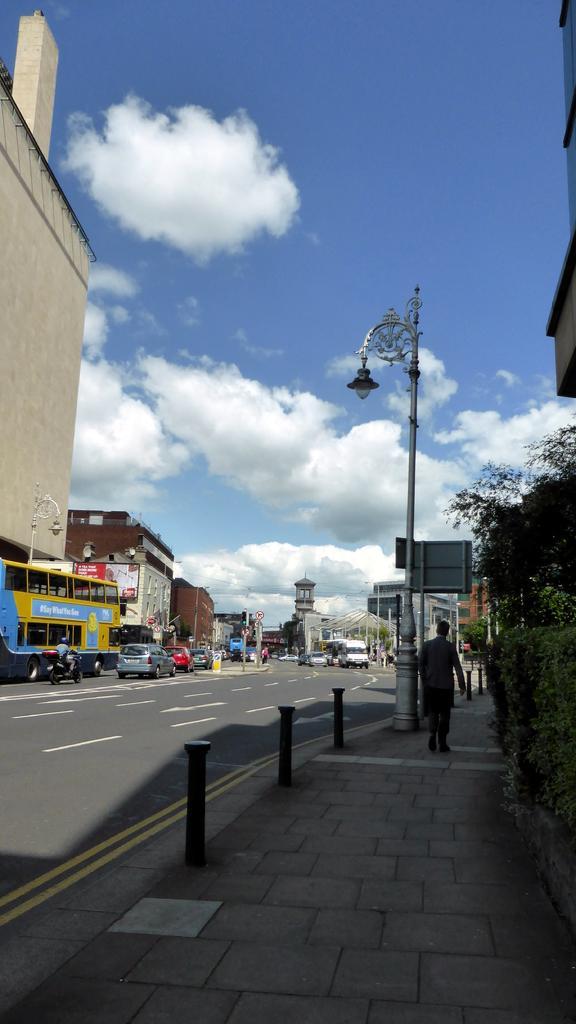Could you give a brief overview of what you see in this image? This picture shows few buildings and we see vehicles moving on both the directions on the road and we see few poles and couple of pole lights and we see a man walking on the sidewalk and we see trees and a blue cloudy sky. 